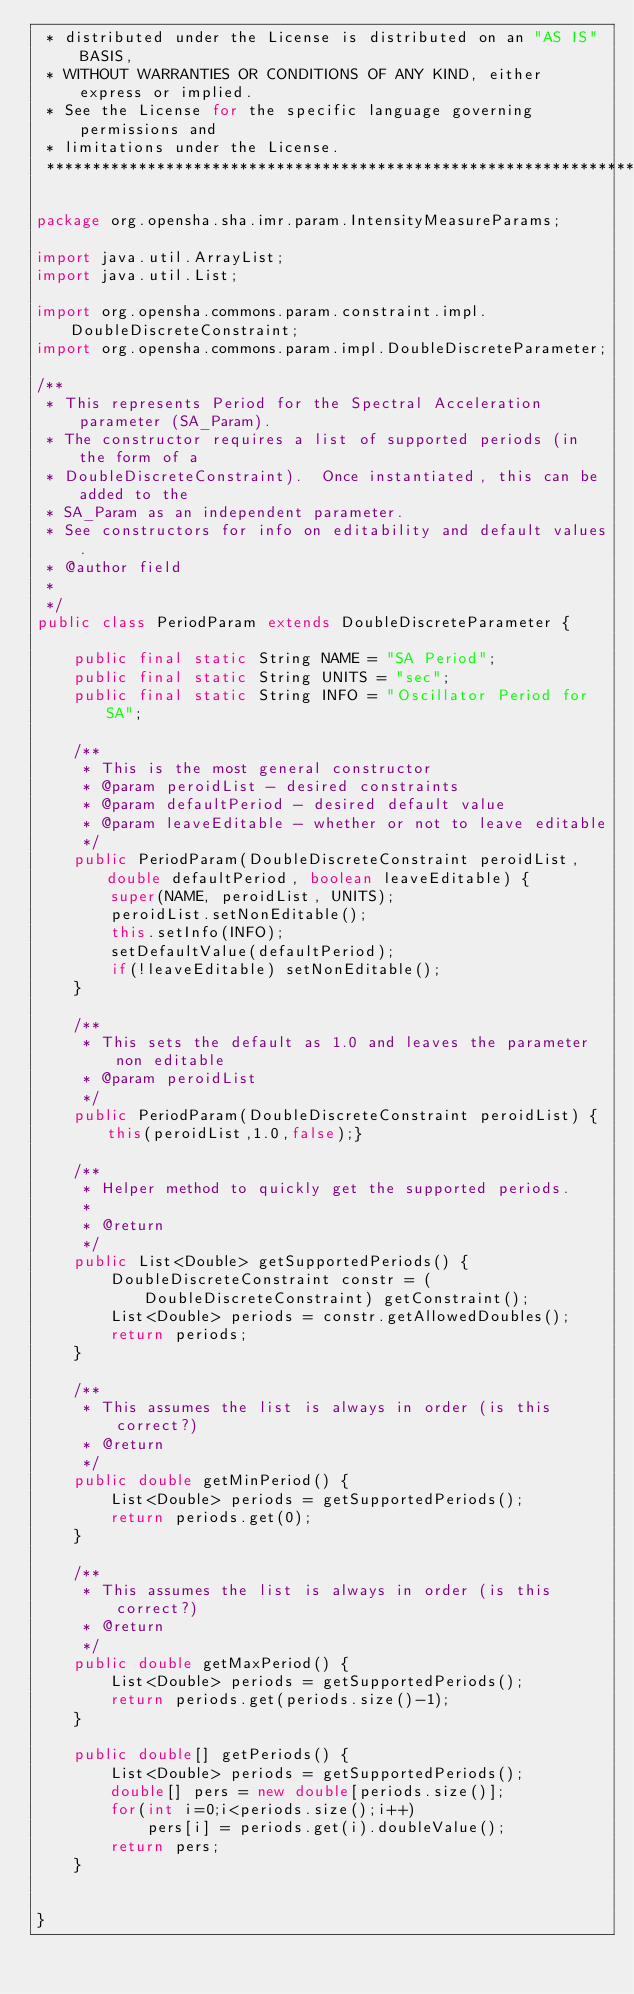Convert code to text. <code><loc_0><loc_0><loc_500><loc_500><_Java_> * distributed under the License is distributed on an "AS IS" BASIS,
 * WITHOUT WARRANTIES OR CONDITIONS OF ANY KIND, either express or implied.
 * See the License for the specific language governing permissions and
 * limitations under the License.
 ******************************************************************************/

package org.opensha.sha.imr.param.IntensityMeasureParams;

import java.util.ArrayList;
import java.util.List;

import org.opensha.commons.param.constraint.impl.DoubleDiscreteConstraint;
import org.opensha.commons.param.impl.DoubleDiscreteParameter;

/**
 * This represents Period for the Spectral Acceleration parameter (SA_Param).  
 * The constructor requires a list of supported periods (in the form of a
 * DoubleDiscreteConstraint).  Once instantiated, this can be added to the
 * SA_Param as an independent parameter.
 * See constructors for info on editability and default values.
 * @author field
 *
 */
public class PeriodParam extends DoubleDiscreteParameter {

	public final static String NAME = "SA Period";
	public final static String UNITS = "sec";
	public final static String INFO = "Oscillator Period for SA";

	/**
	 * This is the most general constructor
	 * @param peroidList - desired constraints
	 * @param defaultPeriod - desired default value
	 * @param leaveEditable - whether or not to leave editable
	 */
	public PeriodParam(DoubleDiscreteConstraint peroidList, double defaultPeriod, boolean leaveEditable) {
		super(NAME, peroidList, UNITS);
		peroidList.setNonEditable();
		this.setInfo(INFO);
		setDefaultValue(defaultPeriod);
		if(!leaveEditable) setNonEditable();
	}
	
	/**
	 * This sets the default as 1.0 and leaves the parameter non editable
	 * @param peroidList
	 */
	public PeriodParam(DoubleDiscreteConstraint peroidList) { this(peroidList,1.0,false);}
	
	/**
	 * Helper method to quickly get the supported periods.
	 * 
	 * @return
	 */
	public List<Double> getSupportedPeriods() {
		DoubleDiscreteConstraint constr = (DoubleDiscreteConstraint) getConstraint();
		List<Double> periods = constr.getAllowedDoubles();
		return periods;
	}
	
	/**
	 * This assumes the list is always in order (is this correct?)
	 * @return
	 */
	public double getMinPeriod() {
		List<Double> periods = getSupportedPeriods();
		return periods.get(0);
	}
	
	/**
	 * This assumes the list is always in order (is this correct?)
	 * @return
	 */
	public double getMaxPeriod() {
		List<Double> periods = getSupportedPeriods();
		return periods.get(periods.size()-1);
	}
	
	public double[] getPeriods() {
		List<Double> periods = getSupportedPeriods();
		double[] pers = new double[periods.size()];
		for(int i=0;i<periods.size();i++)
			pers[i] = periods.get(i).doubleValue();
		return pers;
	}


}
</code> 